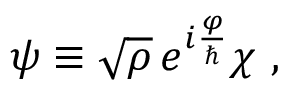Convert formula to latex. <formula><loc_0><loc_0><loc_500><loc_500>\psi \equiv \sqrt { \rho } \, e ^ { i \frac { \varphi } { \hbar } \chi \ ,</formula> 